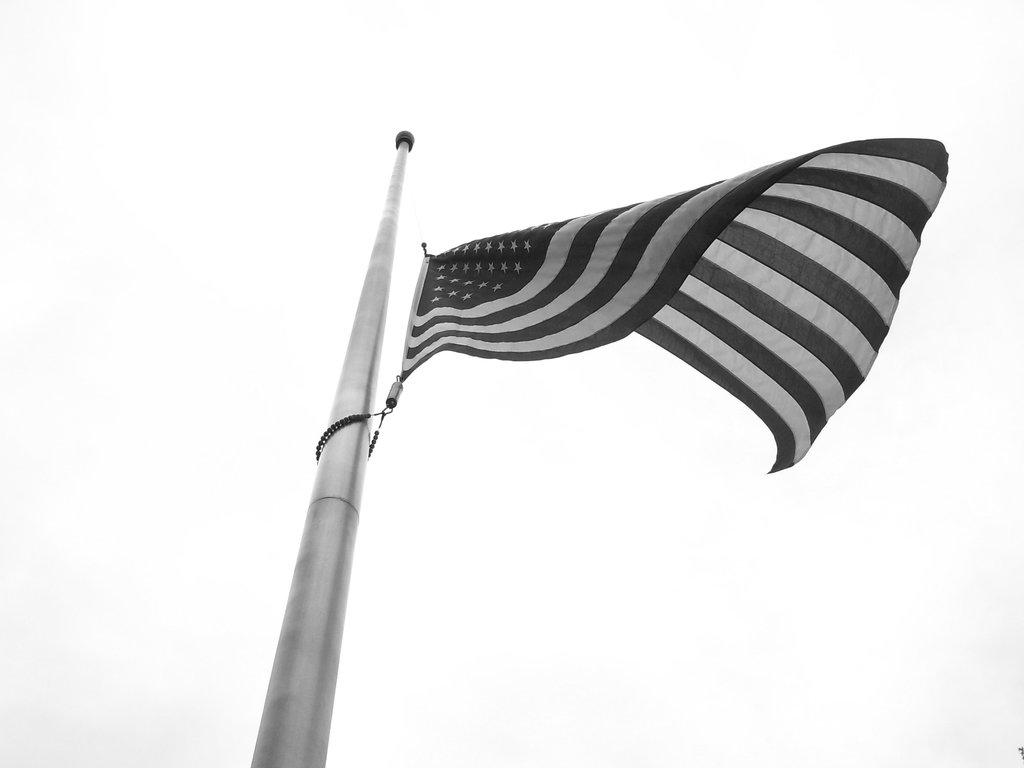What is the main object in the image? There is a stand in the image. What is attached to the stand? A flag is present on the stand. What color is the background of the image? The background of the image is white. What type of joke can be seen on the flag in the image? There is no joke present on the flag in the image. 